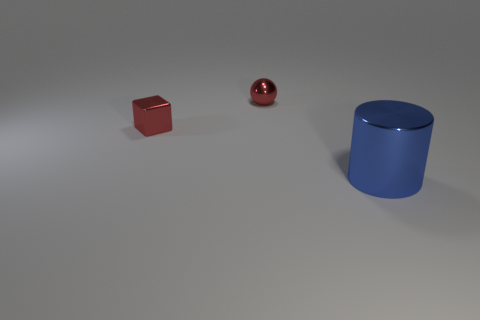Does the shiny sphere have the same size as the metallic cylinder?
Make the answer very short. No. What size is the shiny thing that is to the right of the tiny block and in front of the red ball?
Your answer should be very brief. Large. Is the number of shiny objects that are behind the small metallic cube greater than the number of red metal things that are in front of the blue metal cylinder?
Give a very brief answer. Yes. Does the tiny shiny object that is on the right side of the block have the same color as the shiny cube?
Offer a very short reply. Yes. What number of big purple rubber cubes are there?
Provide a short and direct response. 0. How many red shiny spheres are to the left of the small red object in front of the shiny thing that is behind the tiny red block?
Provide a short and direct response. 0. The blue object is what size?
Give a very brief answer. Large. Is the color of the metallic sphere the same as the shiny cube?
Give a very brief answer. Yes. How big is the metallic object behind the block?
Give a very brief answer. Small. There is a tiny metallic thing that is right of the small red metallic block; is it the same color as the metallic thing on the left side of the ball?
Offer a terse response. Yes. 